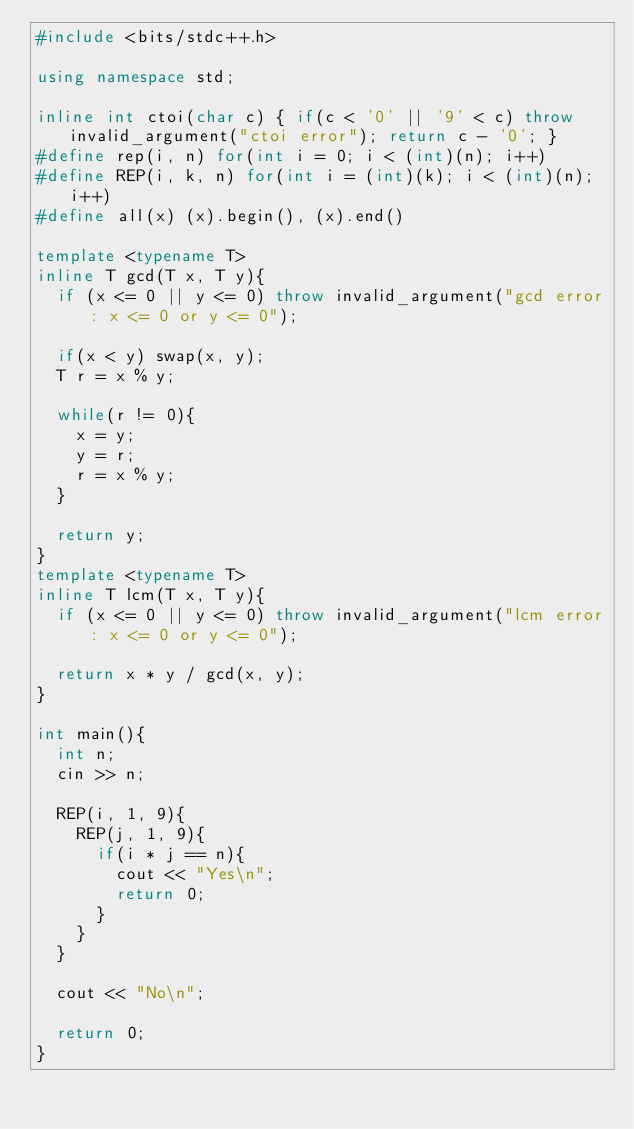<code> <loc_0><loc_0><loc_500><loc_500><_C++_>#include <bits/stdc++.h>

using namespace std;

inline int ctoi(char c) { if(c < '0' || '9' < c) throw invalid_argument("ctoi error"); return c - '0'; }
#define rep(i, n) for(int i = 0; i < (int)(n); i++)
#define REP(i, k, n) for(int i = (int)(k); i < (int)(n); i++)
#define all(x) (x).begin(), (x).end()

template <typename T>
inline T gcd(T x, T y){
	if (x <= 0 || y <= 0) throw invalid_argument("gcd error: x <= 0 or y <= 0");
	
	if(x < y) swap(x, y);
	T r = x % y;

	while(r != 0){
		x = y;
		y = r;
		r = x % y;
	}

	return y;
}
template <typename T>
inline T lcm(T x, T y){
	if (x <= 0 || y <= 0) throw invalid_argument("lcm error: x <= 0 or y <= 0");

	return x * y / gcd(x, y);
}

int main(){
	int n;
	cin >> n;
	
	REP(i, 1, 9){
		REP(j, 1, 9){
			if(i * j == n){
				cout << "Yes\n";
				return 0;
			}
		}
	}

	cout << "No\n";
	
	return 0;
}</code> 